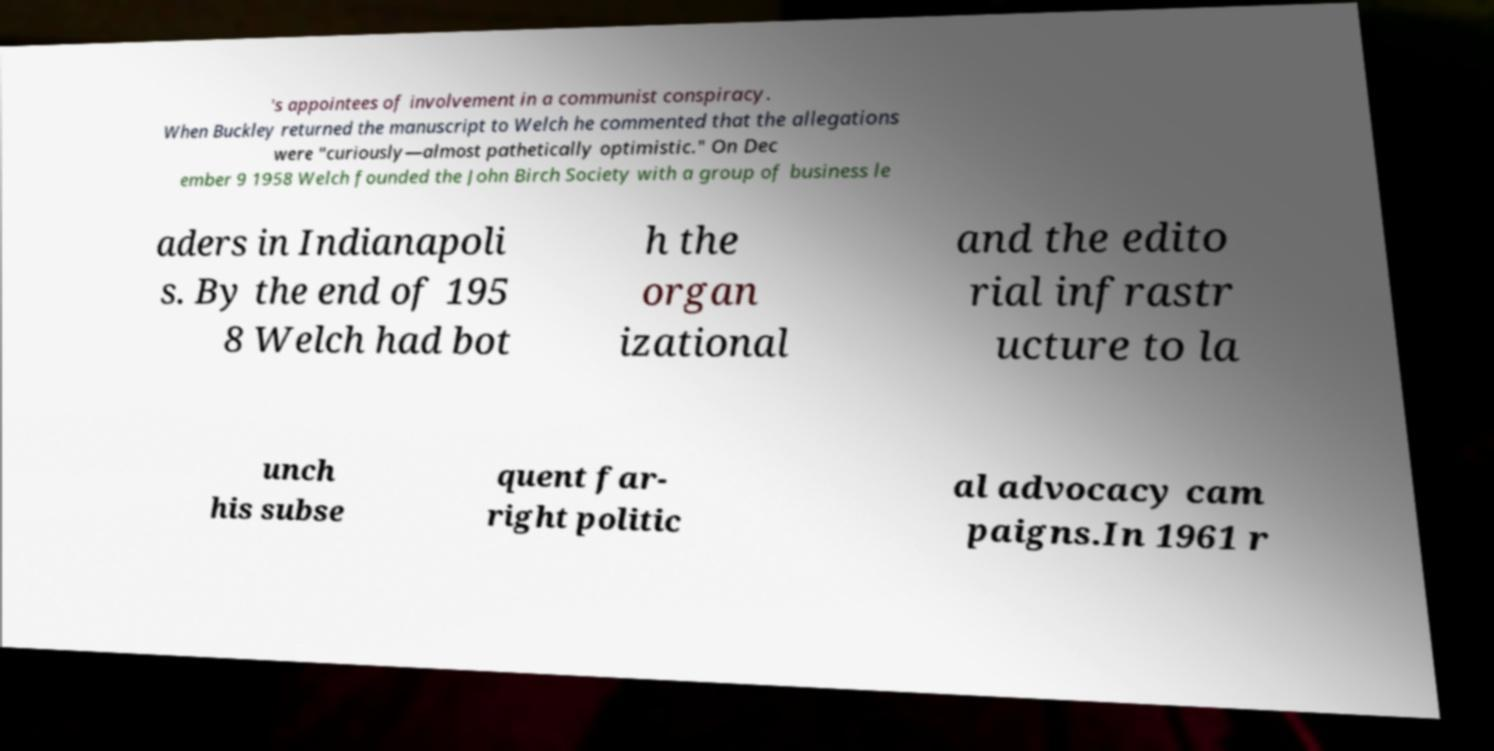I need the written content from this picture converted into text. Can you do that? 's appointees of involvement in a communist conspiracy. When Buckley returned the manuscript to Welch he commented that the allegations were "curiously—almost pathetically optimistic." On Dec ember 9 1958 Welch founded the John Birch Society with a group of business le aders in Indianapoli s. By the end of 195 8 Welch had bot h the organ izational and the edito rial infrastr ucture to la unch his subse quent far- right politic al advocacy cam paigns.In 1961 r 